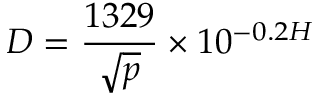<formula> <loc_0><loc_0><loc_500><loc_500>D = { \frac { 1 3 2 9 } { \sqrt { p } } } \times 1 0 ^ { - 0 . 2 H }</formula> 